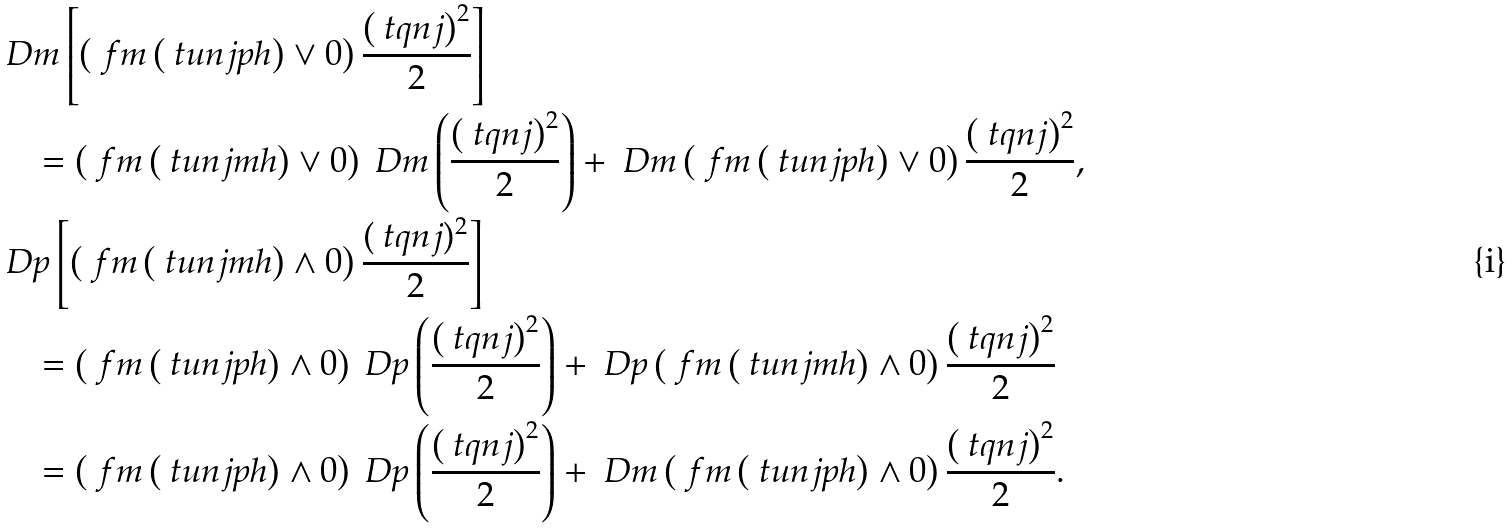Convert formula to latex. <formula><loc_0><loc_0><loc_500><loc_500>& \ D m \left [ \left ( \ f m \left ( \ t u n j p h \right ) \vee 0 \right ) \frac { \left ( \ t q n j \right ) ^ { 2 } } { 2 } \right ] \\ & \quad = \left ( \ f m \left ( \ t u n j m h \right ) \vee 0 \right ) \ D m \left ( \frac { \left ( \ t q n j \right ) ^ { 2 } } { 2 } \right ) + \ D m \left ( \ f m \left ( \ t u n j p h \right ) \vee 0 \right ) \frac { \left ( \ t q n j \right ) ^ { 2 } } { 2 } , \\ & \ D p \left [ \left ( \ f m \left ( \ t u n j m h \right ) \wedge 0 \right ) \frac { ( \ t q n j ) ^ { 2 } } { 2 } \right ] \\ & \quad = \left ( \ f m \left ( \ t u n j p h \right ) \wedge 0 \right ) \ D p \left ( \frac { \left ( \ t q n j \right ) ^ { 2 } } { 2 } \right ) + \ D p \left ( \ f m \left ( \ t u n j m h \right ) \wedge 0 \right ) \frac { \left ( \ t q n j \right ) ^ { 2 } } { 2 } \\ & \quad = \left ( \ f m \left ( \ t u n j p h \right ) \wedge 0 \right ) \ D p \left ( \frac { \left ( \ t q n j \right ) ^ { 2 } } { 2 } \right ) + \ D m \left ( \ f m \left ( \ t u n j p h \right ) \wedge 0 \right ) \frac { \left ( \ t q n j \right ) ^ { 2 } } { 2 } .</formula> 